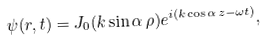Convert formula to latex. <formula><loc_0><loc_0><loc_500><loc_500>\psi ( { r } , t ) = J _ { 0 } ( k \sin \alpha \, \rho ) e ^ { i ( k \cos \alpha \, z - \omega t ) } ,</formula> 